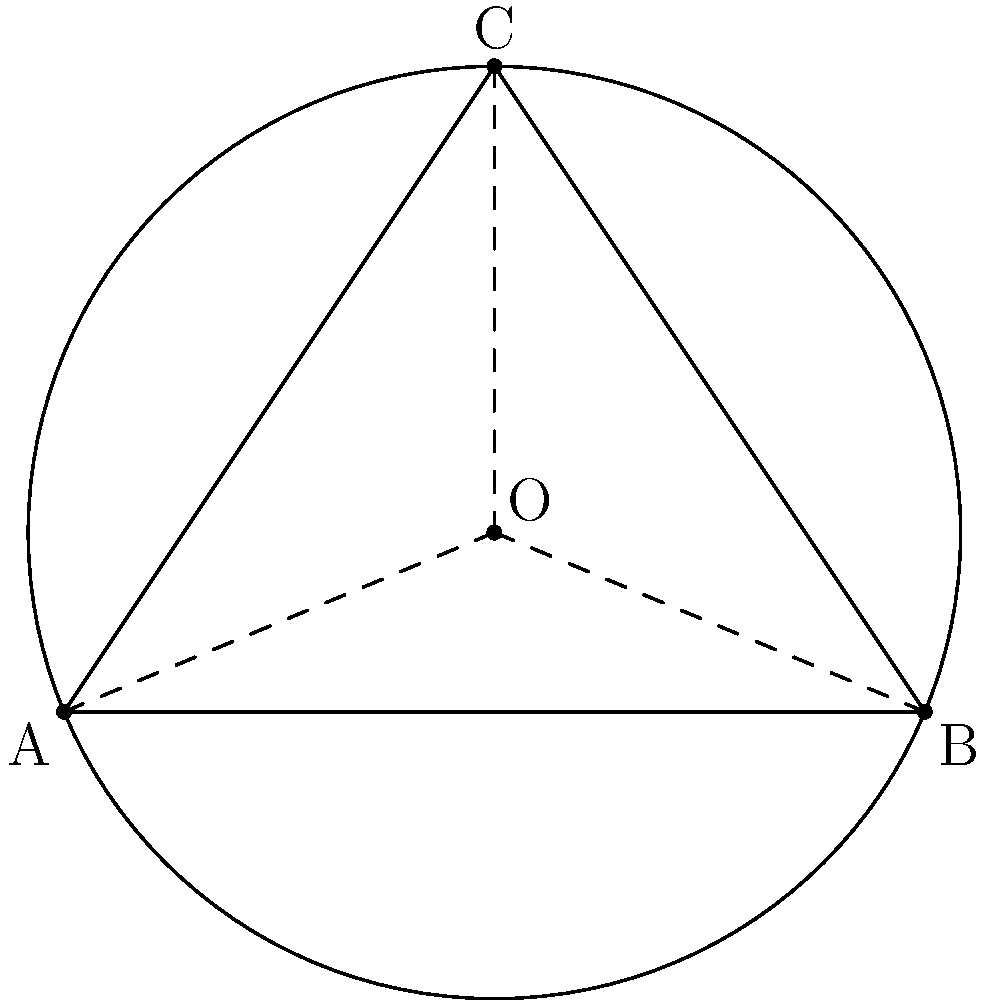You're setting up your drum kit for an outdoor gig, and you need to position your cymbals in a perfect circle around you. You've placed three cymbals at points A(0,0), B(4,0), and C(2,3) on a coordinate plane. Find the coordinates of the center point O of the circle that passes through these three points. To find the center of a circle given three points on its circumference, we can use the perpendicular bisector method:

1) First, we need to find the midpoints of two chords:
   Midpoint of AB: $M_{AB} = (\frac{0+4}{2}, \frac{0+0}{2}) = (2,0)$
   Midpoint of BC: $M_{BC} = (\frac{4+2}{2}, \frac{0+3}{2}) = (3,1.5)$

2) Next, we find the slopes of AB and BC:
   Slope of AB: $m_{AB} = \frac{0-0}{4-0} = 0$
   Slope of BC: $m_{BC} = \frac{3-0}{2-4} = -\frac{3}{2}$

3) The perpendicular bisectors will have slopes that are negative reciprocals of these:
   Slope of perpendicular bisector of AB: $m_1 = \text{undefined}$ (vertical line)
   Slope of perpendicular bisector of BC: $m_2 = \frac{2}{3}$

4) We can now write equations for these perpendicular bisectors:
   Bisector of AB: $x = 2$
   Bisector of BC: $y - 1.5 = \frac{2}{3}(x - 3)$

5) The intersection of these lines is the center of the circle. Substituting $x=2$ into the second equation:
   $y - 1.5 = \frac{2}{3}(2 - 3) = -\frac{2}{3}$
   $y = 1.5 - \frac{2}{3} = \frac{5}{6}$

Therefore, the center O has coordinates $(2, \frac{5}{6})$.
Answer: $(2, \frac{5}{6})$ 